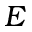<formula> <loc_0><loc_0><loc_500><loc_500>E</formula> 